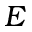<formula> <loc_0><loc_0><loc_500><loc_500>E</formula> 